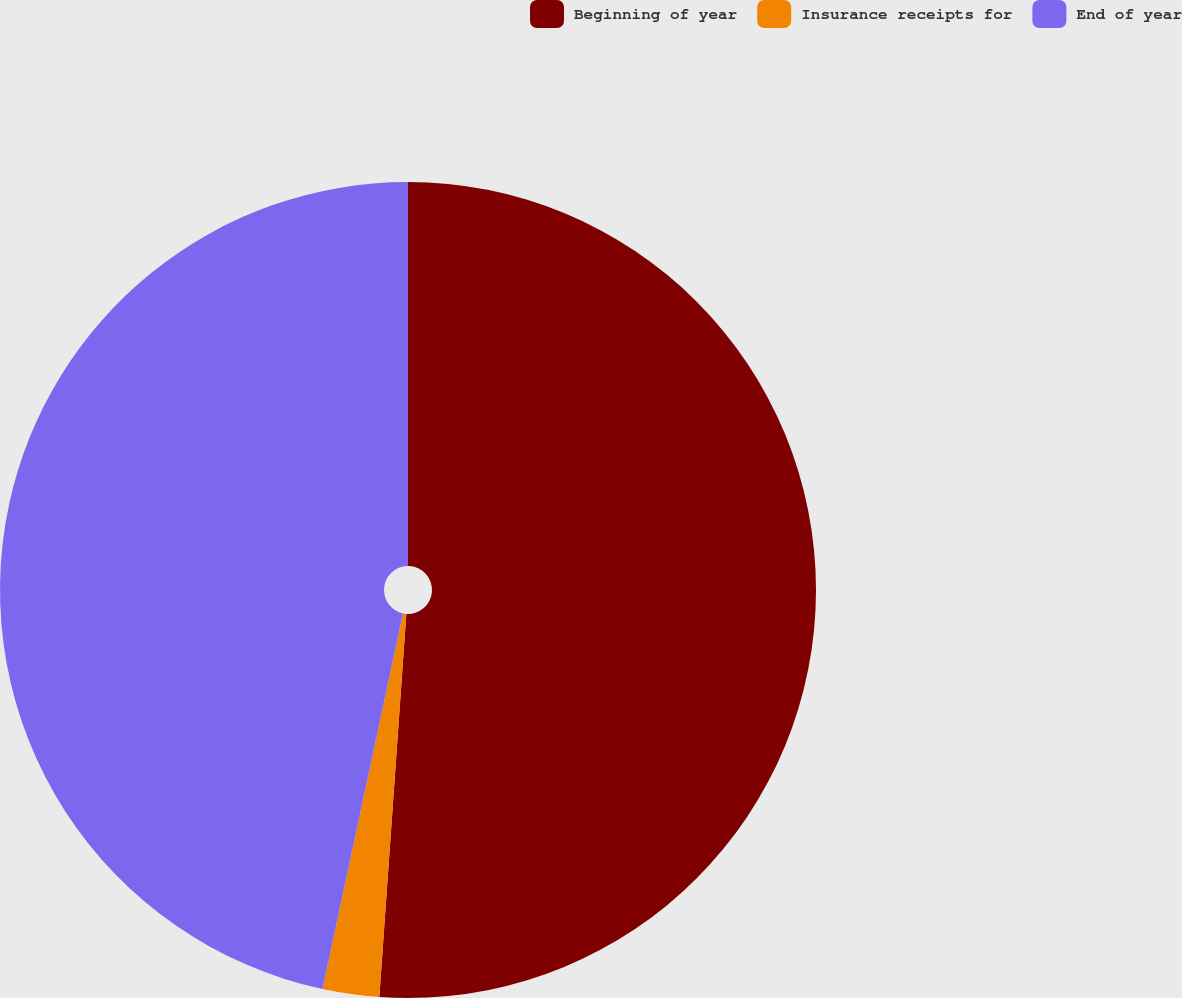Convert chart to OTSL. <chart><loc_0><loc_0><loc_500><loc_500><pie_chart><fcel>Beginning of year<fcel>Insurance receipts for<fcel>End of year<nl><fcel>51.12%<fcel>2.24%<fcel>46.64%<nl></chart> 